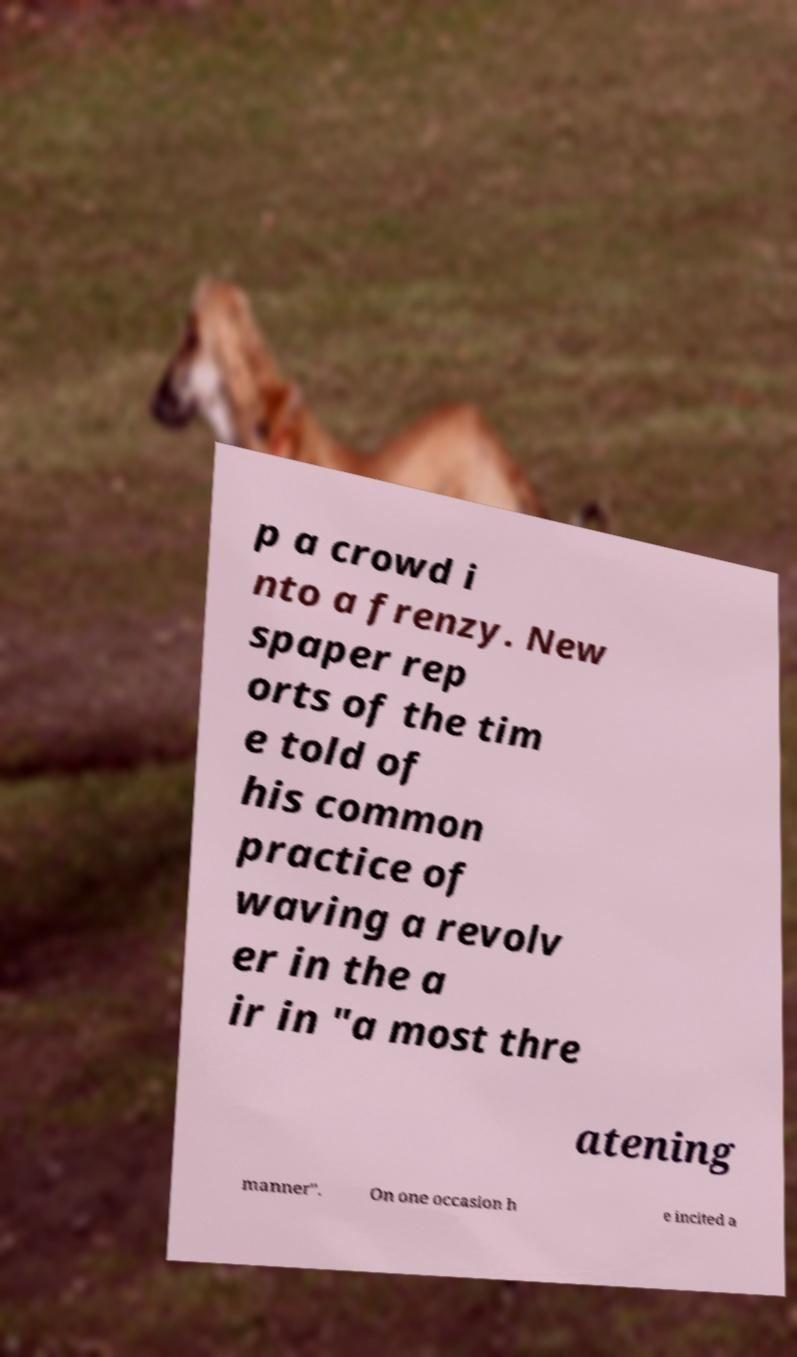Please identify and transcribe the text found in this image. p a crowd i nto a frenzy. New spaper rep orts of the tim e told of his common practice of waving a revolv er in the a ir in "a most thre atening manner". On one occasion h e incited a 